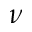<formula> <loc_0><loc_0><loc_500><loc_500>\nu</formula> 